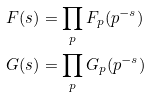Convert formula to latex. <formula><loc_0><loc_0><loc_500><loc_500>F ( s ) & = \prod _ { p } F _ { p } ( p ^ { - s } ) \\ G ( s ) & = \prod _ { p } G _ { p } ( p ^ { - s } )</formula> 